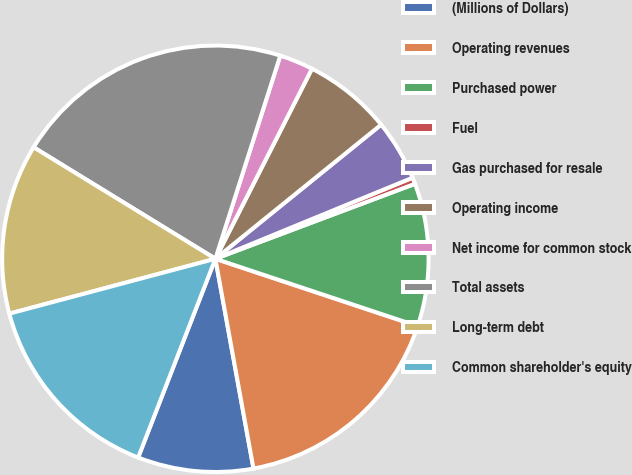<chart> <loc_0><loc_0><loc_500><loc_500><pie_chart><fcel>(Millions of Dollars)<fcel>Operating revenues<fcel>Purchased power<fcel>Fuel<fcel>Gas purchased for resale<fcel>Operating income<fcel>Net income for common stock<fcel>Total assets<fcel>Long-term debt<fcel>Common shareholder's equity<nl><fcel>8.76%<fcel>17.03%<fcel>10.83%<fcel>0.49%<fcel>4.62%<fcel>6.69%<fcel>2.56%<fcel>21.17%<fcel>12.9%<fcel>14.96%<nl></chart> 